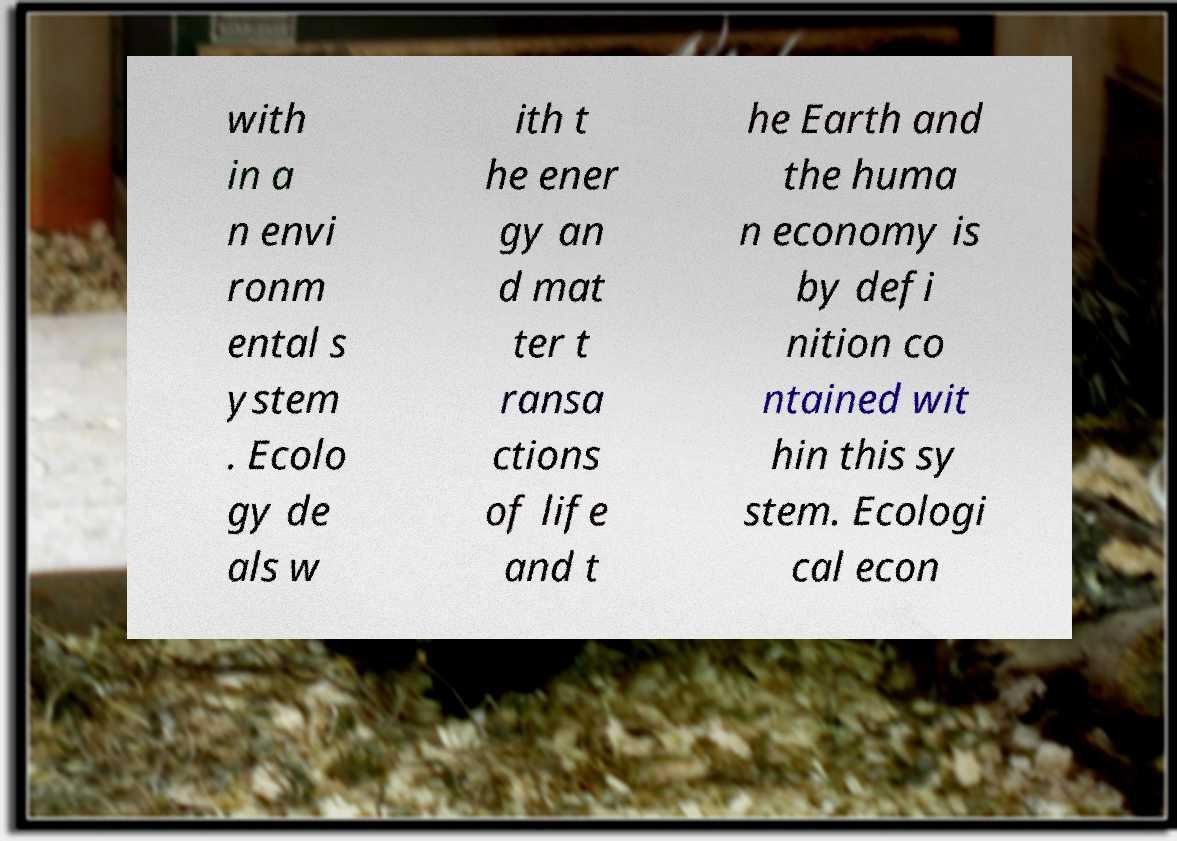What messages or text are displayed in this image? I need them in a readable, typed format. with in a n envi ronm ental s ystem . Ecolo gy de als w ith t he ener gy an d mat ter t ransa ctions of life and t he Earth and the huma n economy is by defi nition co ntained wit hin this sy stem. Ecologi cal econ 